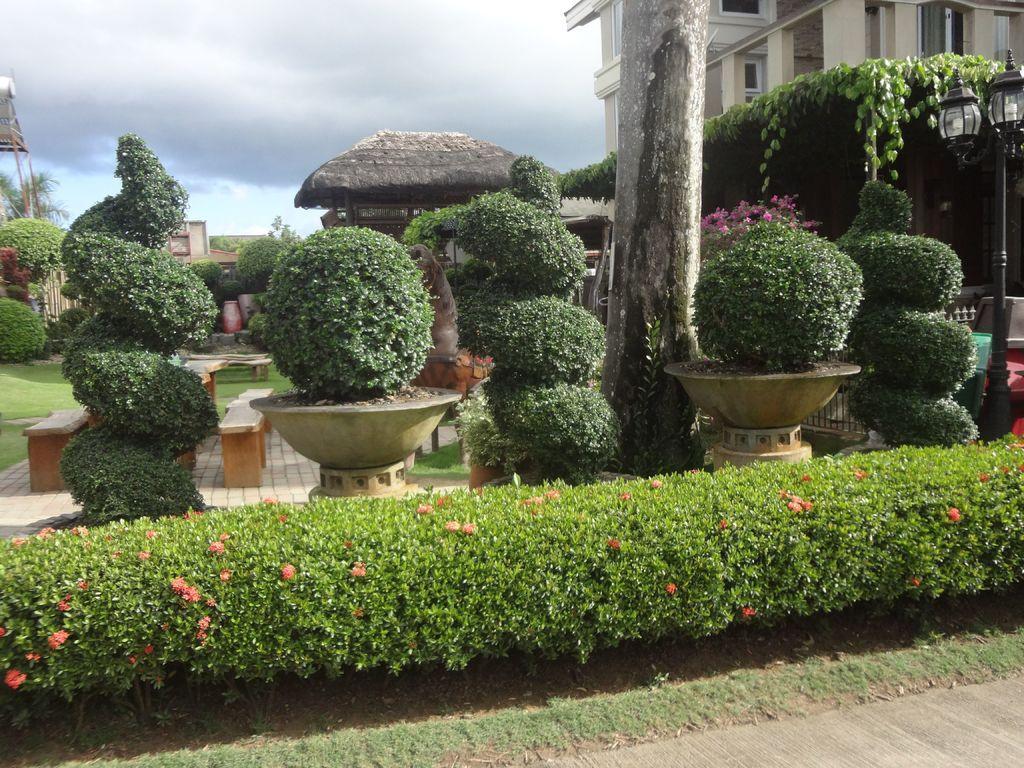In one or two sentences, can you explain what this image depicts? In this image there are plants, in the background there is a building and the sky. 